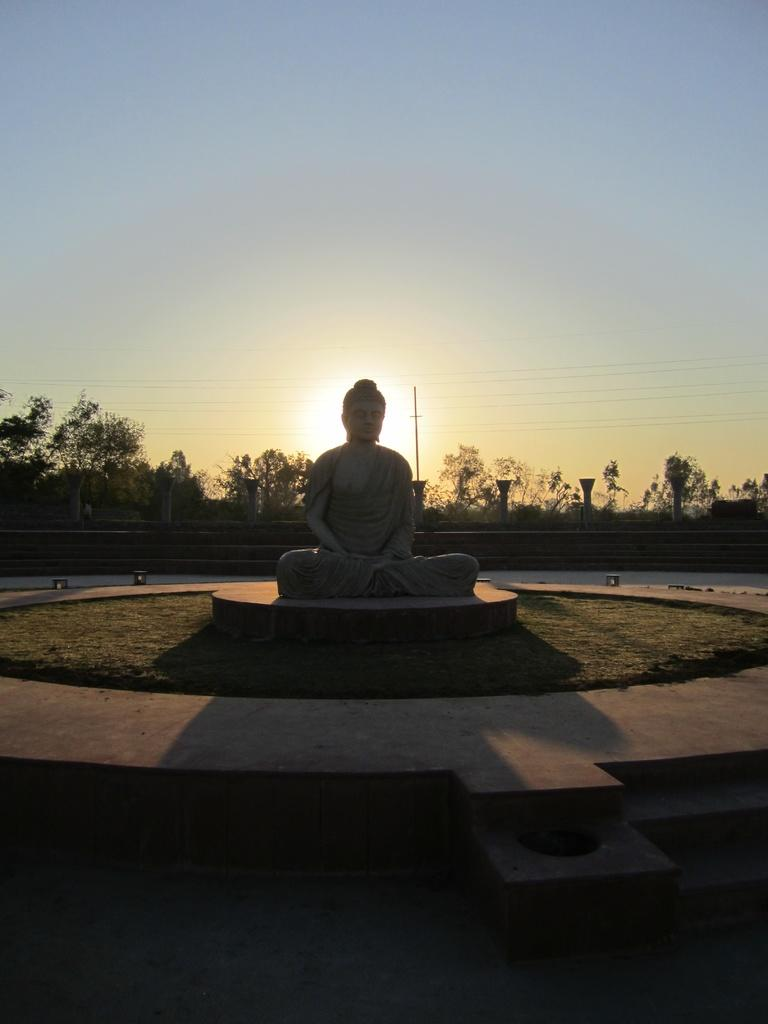What is the main subject in the center of the image? There is a Buddha statue in the image. Where is the statue located in relation to the rest of the image? The statue is in the middle of the image. What can be seen in the background of the image? There are trees in the background of the image. What is visible at the top of the image? The sky is visible at the top of the image. What type of floor surrounds the statue? There is a circular floor around the statue. What scent can be detected coming from the statue in the image? There is no indication of a scent in the image, as it is a photograph and cannot convey smells. 